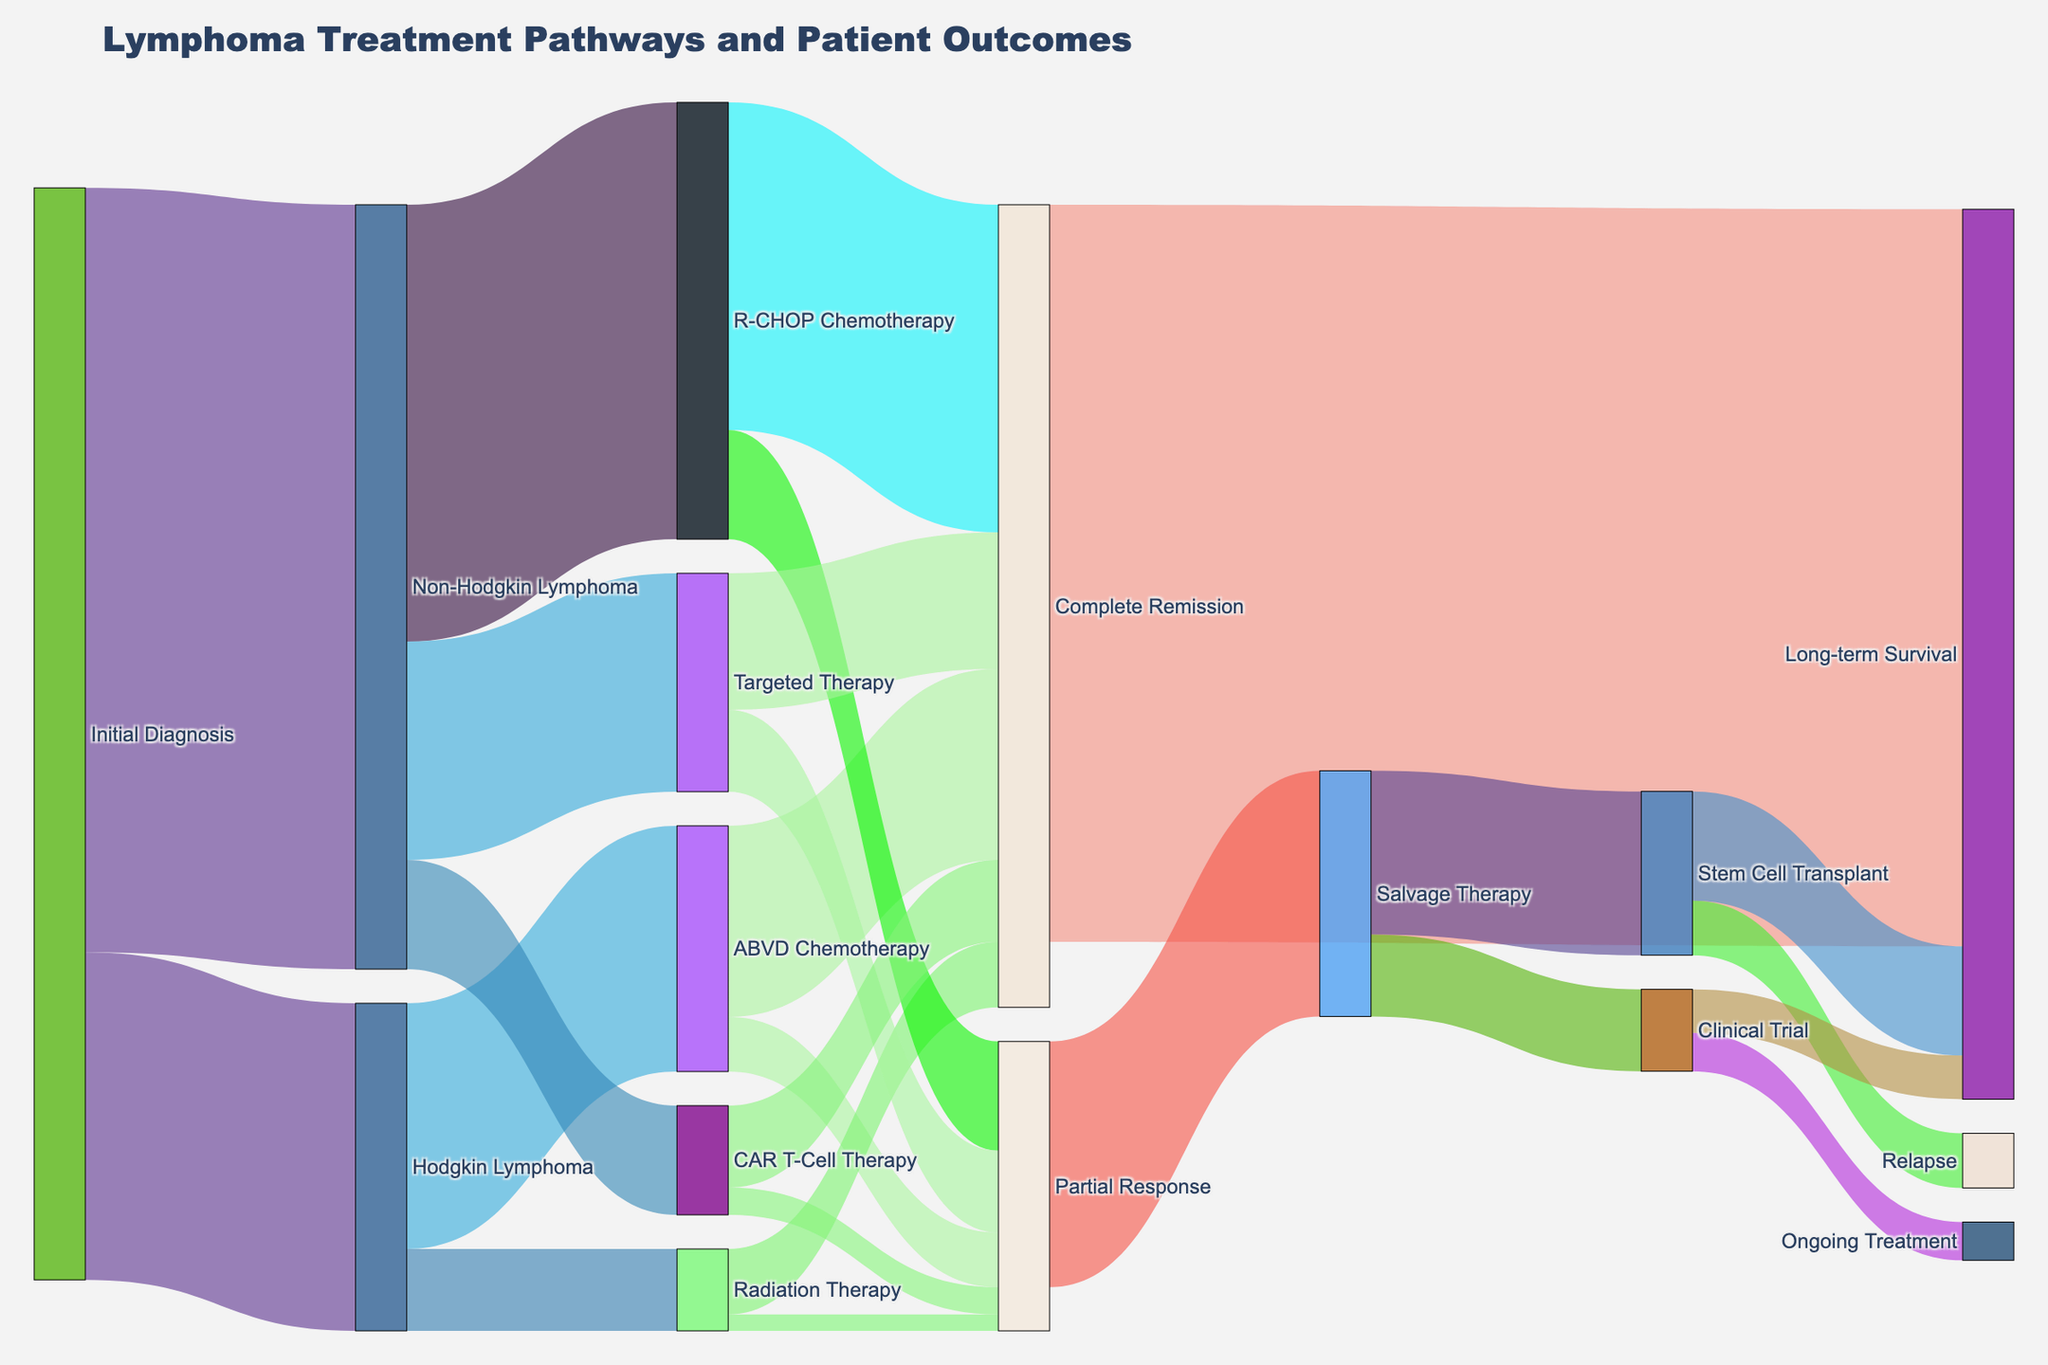What is the title of the figure? The title is usually displayed at the top of the figure to provide a brief description of what the figure is about.
Answer: Lymphoma Treatment Pathways and Patient Outcomes How many pathways lead to Hodgkin Lymphoma from the Initial Diagnosis? To find the number of pathways leading from Initial Diagnosis to Hodgkin Lymphoma, look at the connections that flow directly between these two nodes.
Answer: 1 How many patients were initially diagnosed with Non-Hodgkin Lymphoma? This involves finding the value associated with the pathway from Initial Diagnosis to Non-Hodgkin Lymphoma.
Answer: 140 Which treatment option for Hodgkin Lymphoma leads to a higher rate of complete remission? Compare the values for Complete Remission under both ABVD Chemotherapy and Radiation Therapy.
Answer: ABVD Chemotherapy What paths lead to Long-term Survival for patients initially diagnosed with Non-Hodgkin Lymphoma who go through R-CHOP Chemotherapy and achieve Partial Response? Trace the path from Non-Hodgkin Lymphoma through R-CHOP Chemotherapy to Partial Response, and follow where it leads to Long-term Survival. Partial Response leads to Salvage Therapy which can lead to Stem Cell Transplant or Clinical Trial, and both can result in Long-term Survival.
Answer: Salvage Therapy -> Stem Cell Transplant -> Long-term Survival, and Salvage Therapy -> Clinical Trial -> Long-term Survival Compare the total number of patients achieving Complete Remission from all treatments. Which treatment pathway has the highest number? Sum up the 'Complete Remission' values from ABVD Chemotherapy, Radiation Therapy, R-CHOP Chemotherapy, Targeted Therapy, and CAR T-Cell Therapy. R-CHOP Chemotherapy has the highest individual count.
Answer: R-CHOP Chemotherapy How many patients from Partial Response proceed to Stem Cell Transplant? This requires finding the value associated with Partial Response leading to Salvage Therapy, then to Stem Cell Transplant.
Answer: 30 What is the final outcome for the majority of patients? Look for the node connected to the largest number of pathways marked by the highest cumulative value.
Answer: Long-term Survival 